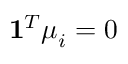<formula> <loc_0><loc_0><loc_500><loc_500>1 ^ { T } \mu _ { i } = 0</formula> 